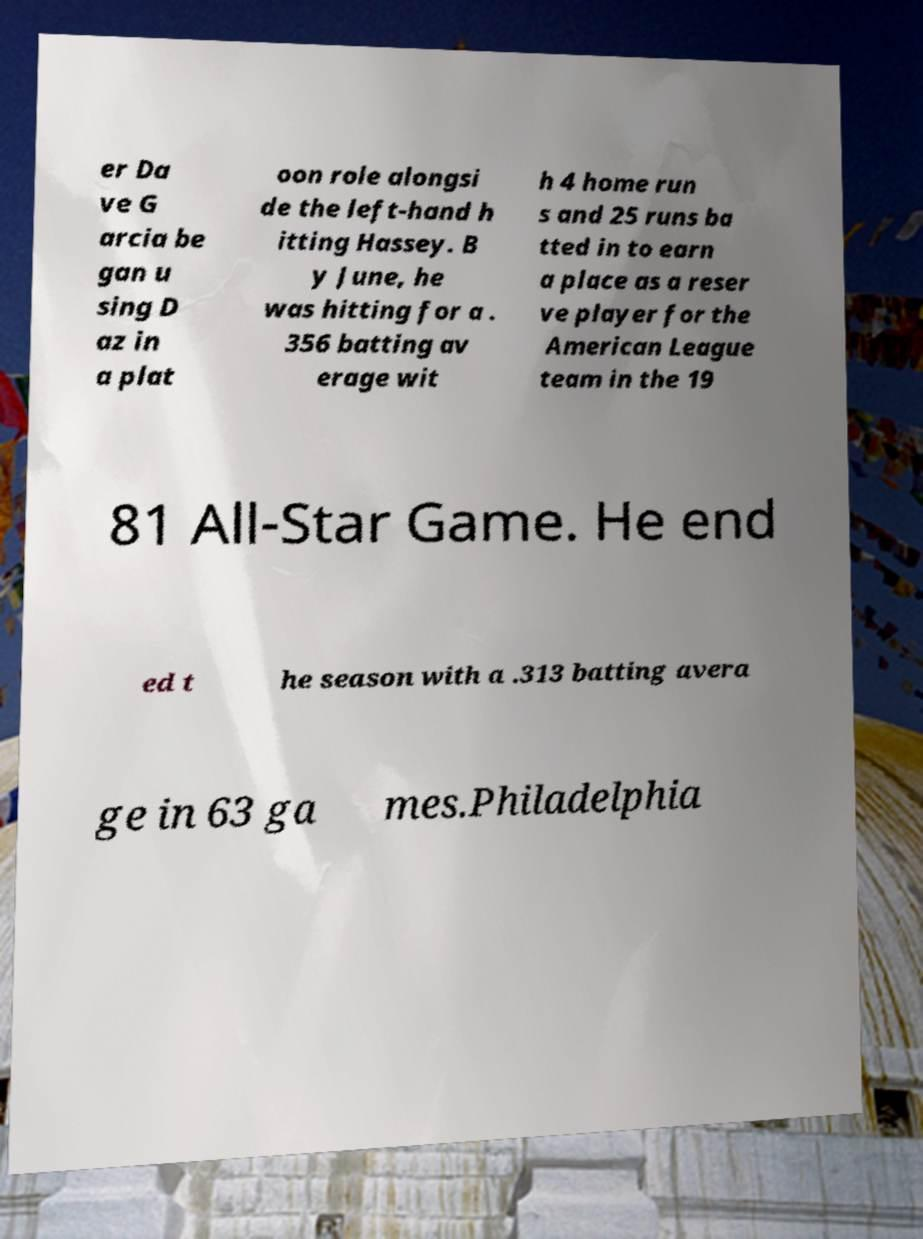Could you extract and type out the text from this image? er Da ve G arcia be gan u sing D az in a plat oon role alongsi de the left-hand h itting Hassey. B y June, he was hitting for a . 356 batting av erage wit h 4 home run s and 25 runs ba tted in to earn a place as a reser ve player for the American League team in the 19 81 All-Star Game. He end ed t he season with a .313 batting avera ge in 63 ga mes.Philadelphia 